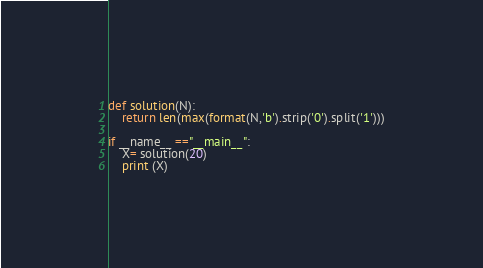<code> <loc_0><loc_0><loc_500><loc_500><_Python_>def solution(N):
    return len(max(format(N,'b').strip('0').split('1')))

if __name__ =="__main__":
    X= solution(20)
    print (X)
</code> 